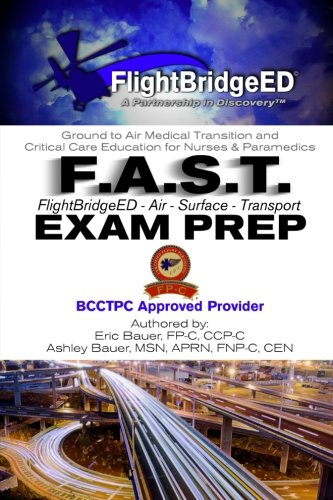Is this a pharmaceutical book? Yes, the book is relevant to the pharmaceutical field as it incorporates elements of pharmaceutical care in emergency medical situations during air and surface transports. 